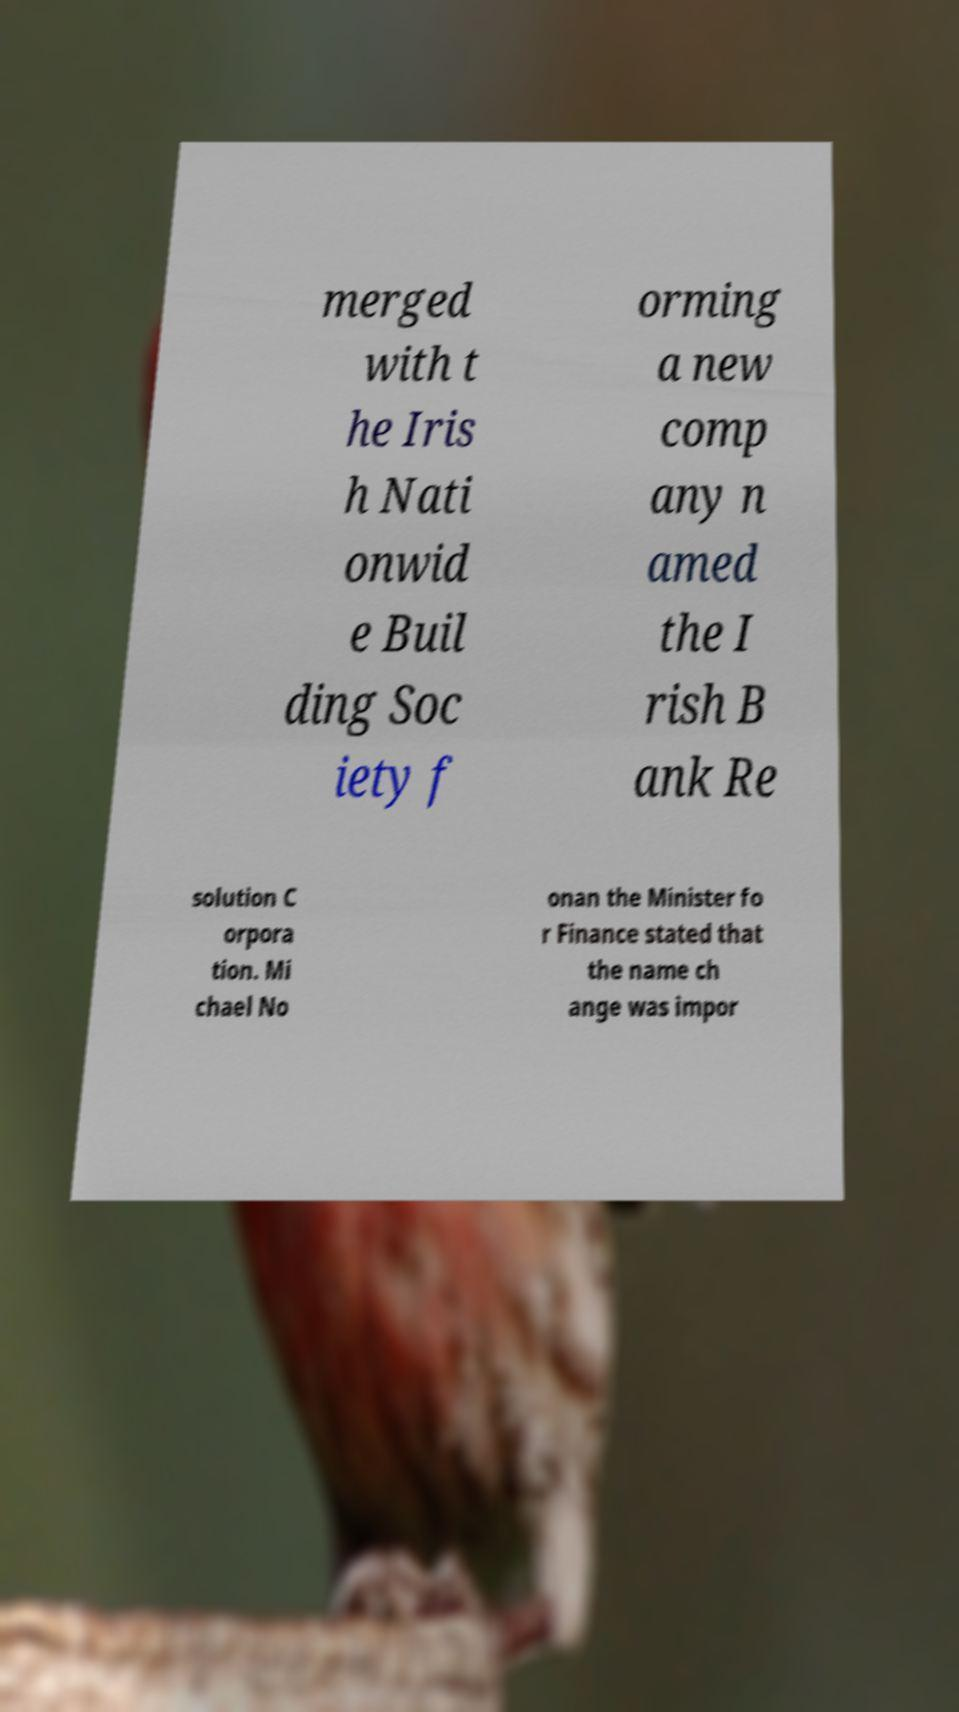Can you read and provide the text displayed in the image?This photo seems to have some interesting text. Can you extract and type it out for me? merged with t he Iris h Nati onwid e Buil ding Soc iety f orming a new comp any n amed the I rish B ank Re solution C orpora tion. Mi chael No onan the Minister fo r Finance stated that the name ch ange was impor 